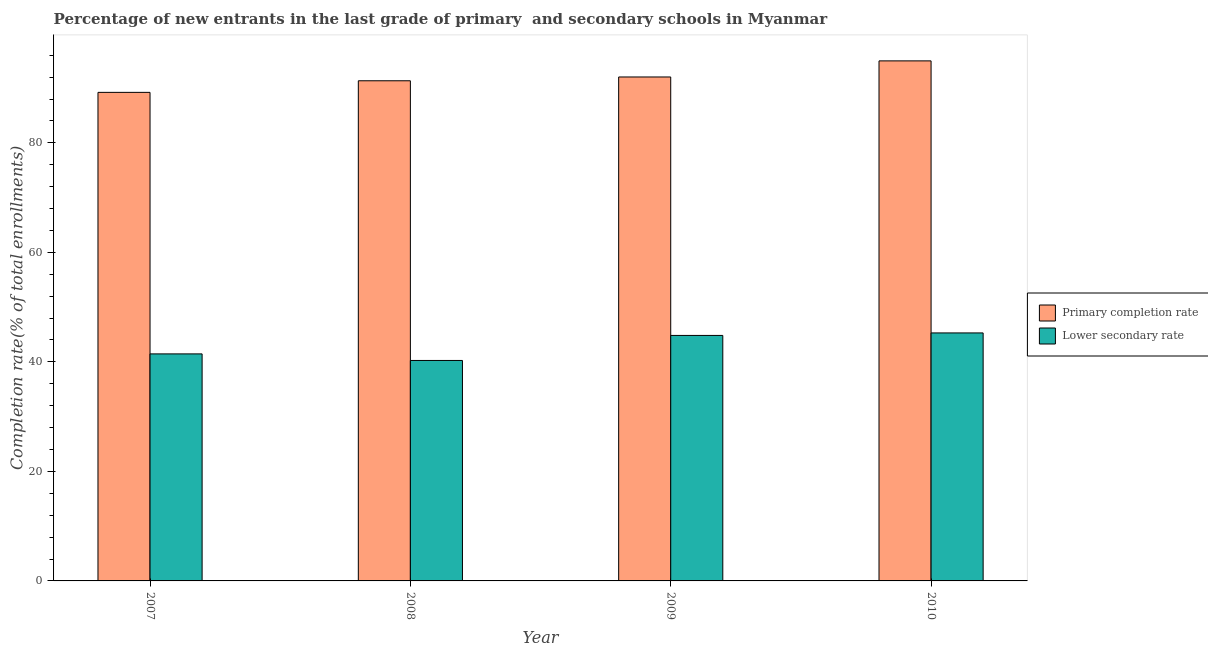How many different coloured bars are there?
Your response must be concise. 2. Are the number of bars per tick equal to the number of legend labels?
Provide a succinct answer. Yes. How many bars are there on the 4th tick from the left?
Your answer should be compact. 2. What is the label of the 1st group of bars from the left?
Offer a very short reply. 2007. What is the completion rate in primary schools in 2009?
Your response must be concise. 92.03. Across all years, what is the maximum completion rate in primary schools?
Offer a terse response. 94.97. Across all years, what is the minimum completion rate in primary schools?
Offer a terse response. 89.21. In which year was the completion rate in secondary schools maximum?
Your answer should be very brief. 2010. In which year was the completion rate in secondary schools minimum?
Your answer should be very brief. 2008. What is the total completion rate in secondary schools in the graph?
Provide a succinct answer. 171.83. What is the difference between the completion rate in secondary schools in 2009 and that in 2010?
Give a very brief answer. -0.46. What is the difference between the completion rate in primary schools in 2009 and the completion rate in secondary schools in 2007?
Give a very brief answer. 2.81. What is the average completion rate in primary schools per year?
Offer a terse response. 91.89. In the year 2008, what is the difference between the completion rate in primary schools and completion rate in secondary schools?
Provide a short and direct response. 0. What is the ratio of the completion rate in primary schools in 2008 to that in 2009?
Your response must be concise. 0.99. What is the difference between the highest and the second highest completion rate in secondary schools?
Your response must be concise. 0.46. What is the difference between the highest and the lowest completion rate in primary schools?
Provide a succinct answer. 5.75. In how many years, is the completion rate in secondary schools greater than the average completion rate in secondary schools taken over all years?
Your answer should be compact. 2. Is the sum of the completion rate in secondary schools in 2007 and 2008 greater than the maximum completion rate in primary schools across all years?
Provide a short and direct response. Yes. What does the 1st bar from the left in 2010 represents?
Provide a short and direct response. Primary completion rate. What does the 2nd bar from the right in 2007 represents?
Your answer should be very brief. Primary completion rate. How many bars are there?
Your response must be concise. 8. Are all the bars in the graph horizontal?
Offer a terse response. No. Does the graph contain grids?
Offer a very short reply. No. How are the legend labels stacked?
Keep it short and to the point. Vertical. What is the title of the graph?
Your response must be concise. Percentage of new entrants in the last grade of primary  and secondary schools in Myanmar. What is the label or title of the Y-axis?
Ensure brevity in your answer.  Completion rate(% of total enrollments). What is the Completion rate(% of total enrollments) of Primary completion rate in 2007?
Provide a succinct answer. 89.21. What is the Completion rate(% of total enrollments) of Lower secondary rate in 2007?
Ensure brevity in your answer.  41.46. What is the Completion rate(% of total enrollments) of Primary completion rate in 2008?
Make the answer very short. 91.33. What is the Completion rate(% of total enrollments) of Lower secondary rate in 2008?
Your response must be concise. 40.26. What is the Completion rate(% of total enrollments) in Primary completion rate in 2009?
Provide a short and direct response. 92.03. What is the Completion rate(% of total enrollments) of Lower secondary rate in 2009?
Keep it short and to the point. 44.83. What is the Completion rate(% of total enrollments) in Primary completion rate in 2010?
Keep it short and to the point. 94.97. What is the Completion rate(% of total enrollments) of Lower secondary rate in 2010?
Provide a succinct answer. 45.29. Across all years, what is the maximum Completion rate(% of total enrollments) of Primary completion rate?
Provide a short and direct response. 94.97. Across all years, what is the maximum Completion rate(% of total enrollments) in Lower secondary rate?
Give a very brief answer. 45.29. Across all years, what is the minimum Completion rate(% of total enrollments) in Primary completion rate?
Ensure brevity in your answer.  89.21. Across all years, what is the minimum Completion rate(% of total enrollments) of Lower secondary rate?
Your answer should be very brief. 40.26. What is the total Completion rate(% of total enrollments) in Primary completion rate in the graph?
Your response must be concise. 367.54. What is the total Completion rate(% of total enrollments) of Lower secondary rate in the graph?
Your answer should be compact. 171.83. What is the difference between the Completion rate(% of total enrollments) in Primary completion rate in 2007 and that in 2008?
Offer a very short reply. -2.12. What is the difference between the Completion rate(% of total enrollments) in Lower secondary rate in 2007 and that in 2008?
Ensure brevity in your answer.  1.2. What is the difference between the Completion rate(% of total enrollments) in Primary completion rate in 2007 and that in 2009?
Give a very brief answer. -2.81. What is the difference between the Completion rate(% of total enrollments) in Lower secondary rate in 2007 and that in 2009?
Your response must be concise. -3.37. What is the difference between the Completion rate(% of total enrollments) in Primary completion rate in 2007 and that in 2010?
Ensure brevity in your answer.  -5.75. What is the difference between the Completion rate(% of total enrollments) of Lower secondary rate in 2007 and that in 2010?
Provide a short and direct response. -3.83. What is the difference between the Completion rate(% of total enrollments) in Primary completion rate in 2008 and that in 2009?
Your response must be concise. -0.69. What is the difference between the Completion rate(% of total enrollments) of Lower secondary rate in 2008 and that in 2009?
Provide a succinct answer. -4.57. What is the difference between the Completion rate(% of total enrollments) of Primary completion rate in 2008 and that in 2010?
Your response must be concise. -3.63. What is the difference between the Completion rate(% of total enrollments) in Lower secondary rate in 2008 and that in 2010?
Provide a short and direct response. -5.03. What is the difference between the Completion rate(% of total enrollments) in Primary completion rate in 2009 and that in 2010?
Ensure brevity in your answer.  -2.94. What is the difference between the Completion rate(% of total enrollments) of Lower secondary rate in 2009 and that in 2010?
Your response must be concise. -0.46. What is the difference between the Completion rate(% of total enrollments) in Primary completion rate in 2007 and the Completion rate(% of total enrollments) in Lower secondary rate in 2008?
Give a very brief answer. 48.96. What is the difference between the Completion rate(% of total enrollments) of Primary completion rate in 2007 and the Completion rate(% of total enrollments) of Lower secondary rate in 2009?
Your response must be concise. 44.39. What is the difference between the Completion rate(% of total enrollments) of Primary completion rate in 2007 and the Completion rate(% of total enrollments) of Lower secondary rate in 2010?
Your answer should be very brief. 43.93. What is the difference between the Completion rate(% of total enrollments) in Primary completion rate in 2008 and the Completion rate(% of total enrollments) in Lower secondary rate in 2009?
Your answer should be compact. 46.51. What is the difference between the Completion rate(% of total enrollments) of Primary completion rate in 2008 and the Completion rate(% of total enrollments) of Lower secondary rate in 2010?
Your response must be concise. 46.05. What is the difference between the Completion rate(% of total enrollments) in Primary completion rate in 2009 and the Completion rate(% of total enrollments) in Lower secondary rate in 2010?
Offer a terse response. 46.74. What is the average Completion rate(% of total enrollments) in Primary completion rate per year?
Offer a very short reply. 91.89. What is the average Completion rate(% of total enrollments) in Lower secondary rate per year?
Provide a succinct answer. 42.96. In the year 2007, what is the difference between the Completion rate(% of total enrollments) of Primary completion rate and Completion rate(% of total enrollments) of Lower secondary rate?
Make the answer very short. 47.76. In the year 2008, what is the difference between the Completion rate(% of total enrollments) in Primary completion rate and Completion rate(% of total enrollments) in Lower secondary rate?
Your answer should be compact. 51.08. In the year 2009, what is the difference between the Completion rate(% of total enrollments) in Primary completion rate and Completion rate(% of total enrollments) in Lower secondary rate?
Provide a short and direct response. 47.2. In the year 2010, what is the difference between the Completion rate(% of total enrollments) of Primary completion rate and Completion rate(% of total enrollments) of Lower secondary rate?
Your response must be concise. 49.68. What is the ratio of the Completion rate(% of total enrollments) of Primary completion rate in 2007 to that in 2008?
Keep it short and to the point. 0.98. What is the ratio of the Completion rate(% of total enrollments) of Lower secondary rate in 2007 to that in 2008?
Make the answer very short. 1.03. What is the ratio of the Completion rate(% of total enrollments) in Primary completion rate in 2007 to that in 2009?
Your answer should be compact. 0.97. What is the ratio of the Completion rate(% of total enrollments) of Lower secondary rate in 2007 to that in 2009?
Your response must be concise. 0.92. What is the ratio of the Completion rate(% of total enrollments) in Primary completion rate in 2007 to that in 2010?
Make the answer very short. 0.94. What is the ratio of the Completion rate(% of total enrollments) of Lower secondary rate in 2007 to that in 2010?
Ensure brevity in your answer.  0.92. What is the ratio of the Completion rate(% of total enrollments) in Primary completion rate in 2008 to that in 2009?
Make the answer very short. 0.99. What is the ratio of the Completion rate(% of total enrollments) in Lower secondary rate in 2008 to that in 2009?
Make the answer very short. 0.9. What is the ratio of the Completion rate(% of total enrollments) of Primary completion rate in 2008 to that in 2010?
Provide a succinct answer. 0.96. What is the difference between the highest and the second highest Completion rate(% of total enrollments) in Primary completion rate?
Keep it short and to the point. 2.94. What is the difference between the highest and the second highest Completion rate(% of total enrollments) of Lower secondary rate?
Make the answer very short. 0.46. What is the difference between the highest and the lowest Completion rate(% of total enrollments) in Primary completion rate?
Ensure brevity in your answer.  5.75. What is the difference between the highest and the lowest Completion rate(% of total enrollments) of Lower secondary rate?
Offer a terse response. 5.03. 